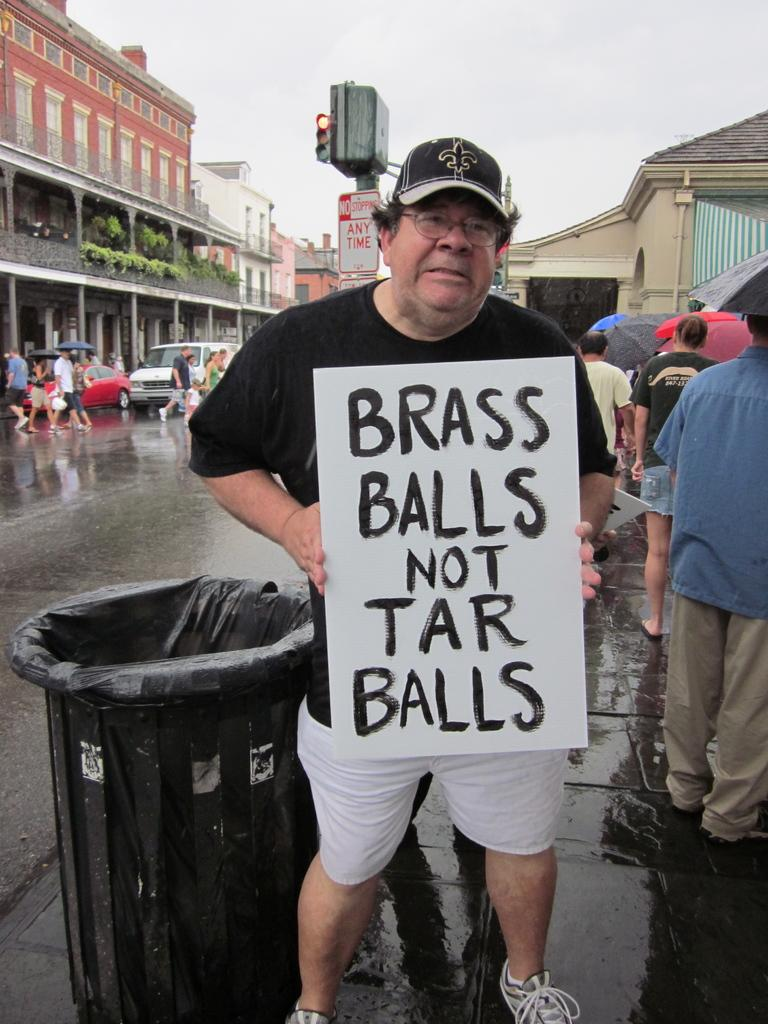<image>
Present a compact description of the photo's key features. A man is carrying a brass balls not tar balls sign. 